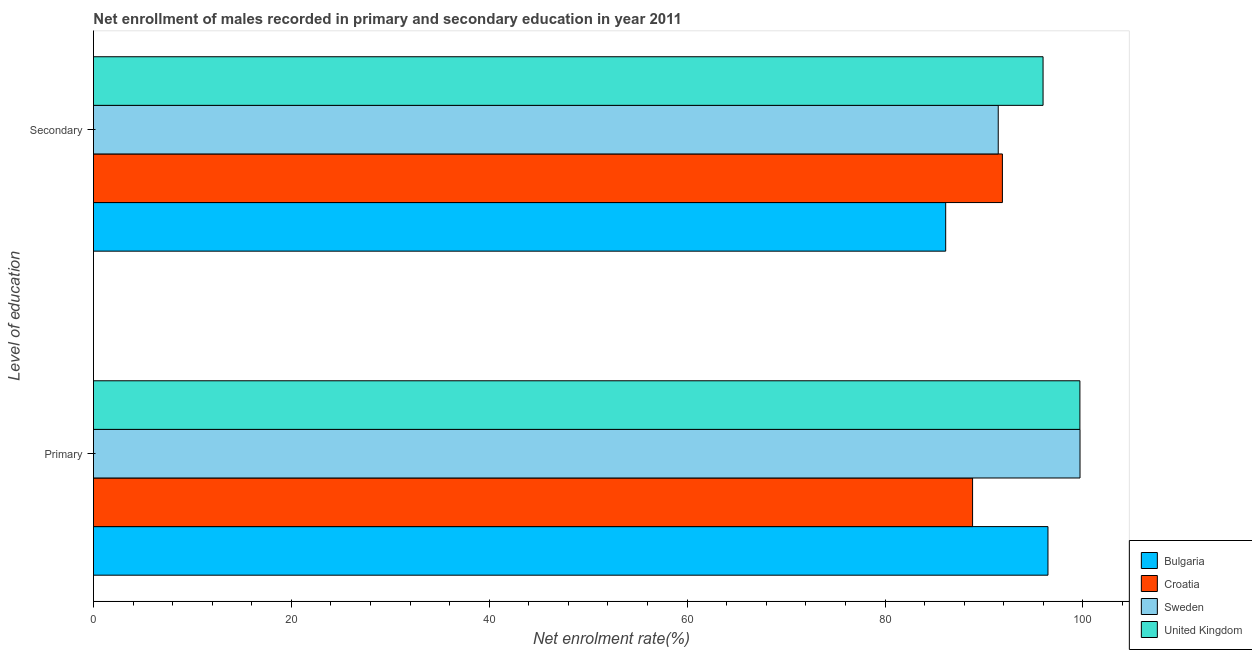How many different coloured bars are there?
Your response must be concise. 4. How many groups of bars are there?
Provide a short and direct response. 2. Are the number of bars per tick equal to the number of legend labels?
Ensure brevity in your answer.  Yes. What is the label of the 2nd group of bars from the top?
Your response must be concise. Primary. What is the enrollment rate in secondary education in Sweden?
Ensure brevity in your answer.  91.44. Across all countries, what is the maximum enrollment rate in primary education?
Keep it short and to the point. 99.7. Across all countries, what is the minimum enrollment rate in primary education?
Your response must be concise. 88.85. In which country was the enrollment rate in secondary education minimum?
Ensure brevity in your answer.  Bulgaria. What is the total enrollment rate in secondary education in the graph?
Your answer should be very brief. 365.4. What is the difference between the enrollment rate in primary education in United Kingdom and that in Sweden?
Ensure brevity in your answer.  -0.01. What is the difference between the enrollment rate in primary education in United Kingdom and the enrollment rate in secondary education in Bulgaria?
Keep it short and to the point. 13.56. What is the average enrollment rate in secondary education per country?
Your answer should be compact. 91.35. What is the difference between the enrollment rate in secondary education and enrollment rate in primary education in Croatia?
Keep it short and to the point. 3.01. What is the ratio of the enrollment rate in secondary education in Bulgaria to that in Croatia?
Ensure brevity in your answer.  0.94. In how many countries, is the enrollment rate in primary education greater than the average enrollment rate in primary education taken over all countries?
Provide a succinct answer. 3. What does the 3rd bar from the top in Primary represents?
Your answer should be very brief. Croatia. Are all the bars in the graph horizontal?
Ensure brevity in your answer.  Yes. How many countries are there in the graph?
Offer a very short reply. 4. What is the difference between two consecutive major ticks on the X-axis?
Your answer should be compact. 20. Does the graph contain grids?
Your response must be concise. No. How many legend labels are there?
Keep it short and to the point. 4. What is the title of the graph?
Keep it short and to the point. Net enrollment of males recorded in primary and secondary education in year 2011. What is the label or title of the X-axis?
Your answer should be very brief. Net enrolment rate(%). What is the label or title of the Y-axis?
Make the answer very short. Level of education. What is the Net enrolment rate(%) in Bulgaria in Primary?
Your answer should be very brief. 96.47. What is the Net enrolment rate(%) of Croatia in Primary?
Keep it short and to the point. 88.85. What is the Net enrolment rate(%) of Sweden in Primary?
Make the answer very short. 99.7. What is the Net enrolment rate(%) in United Kingdom in Primary?
Your answer should be very brief. 99.69. What is the Net enrolment rate(%) in Bulgaria in Secondary?
Offer a very short reply. 86.13. What is the Net enrolment rate(%) in Croatia in Secondary?
Your answer should be very brief. 91.86. What is the Net enrolment rate(%) of Sweden in Secondary?
Make the answer very short. 91.44. What is the Net enrolment rate(%) of United Kingdom in Secondary?
Your answer should be compact. 95.97. Across all Level of education, what is the maximum Net enrolment rate(%) in Bulgaria?
Make the answer very short. 96.47. Across all Level of education, what is the maximum Net enrolment rate(%) in Croatia?
Your answer should be compact. 91.86. Across all Level of education, what is the maximum Net enrolment rate(%) in Sweden?
Your response must be concise. 99.7. Across all Level of education, what is the maximum Net enrolment rate(%) in United Kingdom?
Your answer should be very brief. 99.69. Across all Level of education, what is the minimum Net enrolment rate(%) of Bulgaria?
Your answer should be very brief. 86.13. Across all Level of education, what is the minimum Net enrolment rate(%) in Croatia?
Your answer should be very brief. 88.85. Across all Level of education, what is the minimum Net enrolment rate(%) of Sweden?
Provide a short and direct response. 91.44. Across all Level of education, what is the minimum Net enrolment rate(%) in United Kingdom?
Give a very brief answer. 95.97. What is the total Net enrolment rate(%) of Bulgaria in the graph?
Ensure brevity in your answer.  182.6. What is the total Net enrolment rate(%) in Croatia in the graph?
Keep it short and to the point. 180.71. What is the total Net enrolment rate(%) in Sweden in the graph?
Ensure brevity in your answer.  191.14. What is the total Net enrolment rate(%) in United Kingdom in the graph?
Give a very brief answer. 195.66. What is the difference between the Net enrolment rate(%) in Bulgaria in Primary and that in Secondary?
Offer a very short reply. 10.34. What is the difference between the Net enrolment rate(%) in Croatia in Primary and that in Secondary?
Give a very brief answer. -3.01. What is the difference between the Net enrolment rate(%) in Sweden in Primary and that in Secondary?
Your answer should be compact. 8.26. What is the difference between the Net enrolment rate(%) of United Kingdom in Primary and that in Secondary?
Make the answer very short. 3.72. What is the difference between the Net enrolment rate(%) in Bulgaria in Primary and the Net enrolment rate(%) in Croatia in Secondary?
Offer a very short reply. 4.61. What is the difference between the Net enrolment rate(%) of Bulgaria in Primary and the Net enrolment rate(%) of Sweden in Secondary?
Your answer should be compact. 5.03. What is the difference between the Net enrolment rate(%) in Bulgaria in Primary and the Net enrolment rate(%) in United Kingdom in Secondary?
Your response must be concise. 0.5. What is the difference between the Net enrolment rate(%) of Croatia in Primary and the Net enrolment rate(%) of Sweden in Secondary?
Provide a short and direct response. -2.59. What is the difference between the Net enrolment rate(%) in Croatia in Primary and the Net enrolment rate(%) in United Kingdom in Secondary?
Your answer should be compact. -7.12. What is the difference between the Net enrolment rate(%) in Sweden in Primary and the Net enrolment rate(%) in United Kingdom in Secondary?
Give a very brief answer. 3.73. What is the average Net enrolment rate(%) in Bulgaria per Level of education?
Keep it short and to the point. 91.3. What is the average Net enrolment rate(%) of Croatia per Level of education?
Your answer should be very brief. 90.35. What is the average Net enrolment rate(%) in Sweden per Level of education?
Your response must be concise. 95.57. What is the average Net enrolment rate(%) in United Kingdom per Level of education?
Make the answer very short. 97.83. What is the difference between the Net enrolment rate(%) of Bulgaria and Net enrolment rate(%) of Croatia in Primary?
Offer a very short reply. 7.62. What is the difference between the Net enrolment rate(%) of Bulgaria and Net enrolment rate(%) of Sweden in Primary?
Keep it short and to the point. -3.24. What is the difference between the Net enrolment rate(%) of Bulgaria and Net enrolment rate(%) of United Kingdom in Primary?
Offer a terse response. -3.23. What is the difference between the Net enrolment rate(%) in Croatia and Net enrolment rate(%) in Sweden in Primary?
Offer a terse response. -10.86. What is the difference between the Net enrolment rate(%) in Croatia and Net enrolment rate(%) in United Kingdom in Primary?
Your answer should be very brief. -10.85. What is the difference between the Net enrolment rate(%) of Sweden and Net enrolment rate(%) of United Kingdom in Primary?
Provide a succinct answer. 0.01. What is the difference between the Net enrolment rate(%) of Bulgaria and Net enrolment rate(%) of Croatia in Secondary?
Ensure brevity in your answer.  -5.73. What is the difference between the Net enrolment rate(%) in Bulgaria and Net enrolment rate(%) in Sweden in Secondary?
Keep it short and to the point. -5.31. What is the difference between the Net enrolment rate(%) in Bulgaria and Net enrolment rate(%) in United Kingdom in Secondary?
Make the answer very short. -9.84. What is the difference between the Net enrolment rate(%) in Croatia and Net enrolment rate(%) in Sweden in Secondary?
Keep it short and to the point. 0.42. What is the difference between the Net enrolment rate(%) of Croatia and Net enrolment rate(%) of United Kingdom in Secondary?
Your answer should be very brief. -4.11. What is the difference between the Net enrolment rate(%) in Sweden and Net enrolment rate(%) in United Kingdom in Secondary?
Offer a terse response. -4.53. What is the ratio of the Net enrolment rate(%) in Bulgaria in Primary to that in Secondary?
Make the answer very short. 1.12. What is the ratio of the Net enrolment rate(%) in Croatia in Primary to that in Secondary?
Make the answer very short. 0.97. What is the ratio of the Net enrolment rate(%) in Sweden in Primary to that in Secondary?
Make the answer very short. 1.09. What is the ratio of the Net enrolment rate(%) of United Kingdom in Primary to that in Secondary?
Provide a short and direct response. 1.04. What is the difference between the highest and the second highest Net enrolment rate(%) of Bulgaria?
Make the answer very short. 10.34. What is the difference between the highest and the second highest Net enrolment rate(%) of Croatia?
Give a very brief answer. 3.01. What is the difference between the highest and the second highest Net enrolment rate(%) in Sweden?
Offer a terse response. 8.26. What is the difference between the highest and the second highest Net enrolment rate(%) of United Kingdom?
Make the answer very short. 3.72. What is the difference between the highest and the lowest Net enrolment rate(%) of Bulgaria?
Make the answer very short. 10.34. What is the difference between the highest and the lowest Net enrolment rate(%) in Croatia?
Keep it short and to the point. 3.01. What is the difference between the highest and the lowest Net enrolment rate(%) of Sweden?
Offer a very short reply. 8.26. What is the difference between the highest and the lowest Net enrolment rate(%) in United Kingdom?
Make the answer very short. 3.72. 